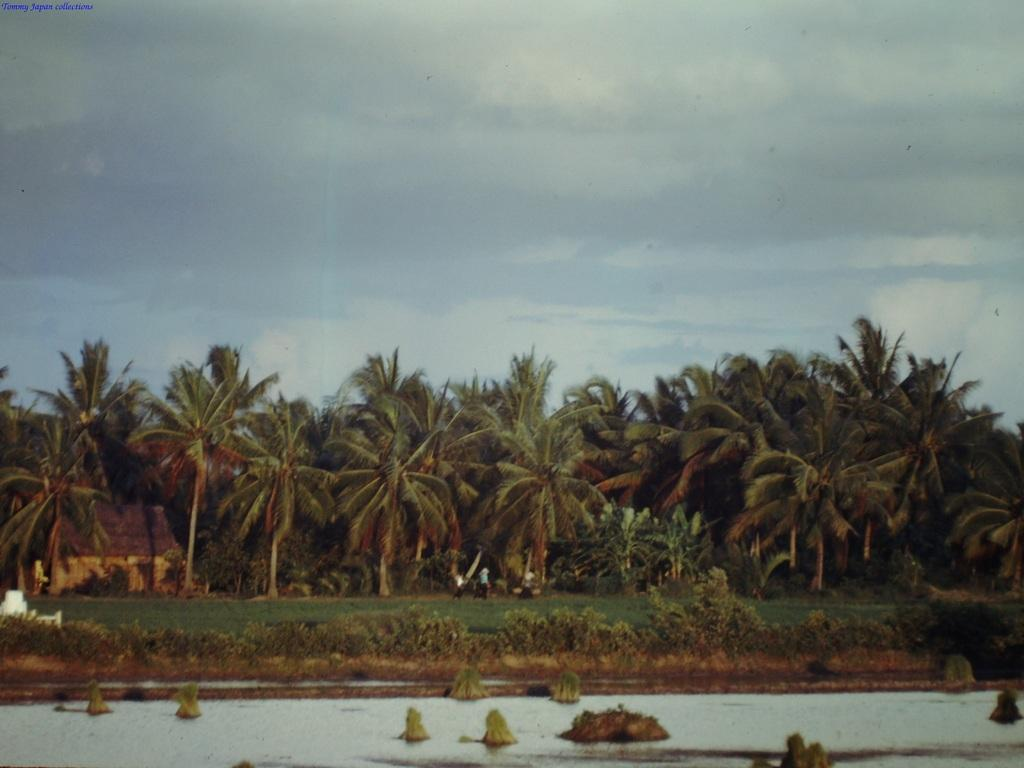What is the primary element visible in the image? There is water in the image. What can be seen in the background of the image? There are people walking in the background. What type of vegetation is present in the image? There is grass and trees in the image. What is the color of the sky in the image? The sky is blue and white in color. What type of clock is being discussed by the people in the image? There is no clock present in the image, nor is there any indication of a discussion about a clock. Can you see an apple in the image? There is no apple present in the image. 